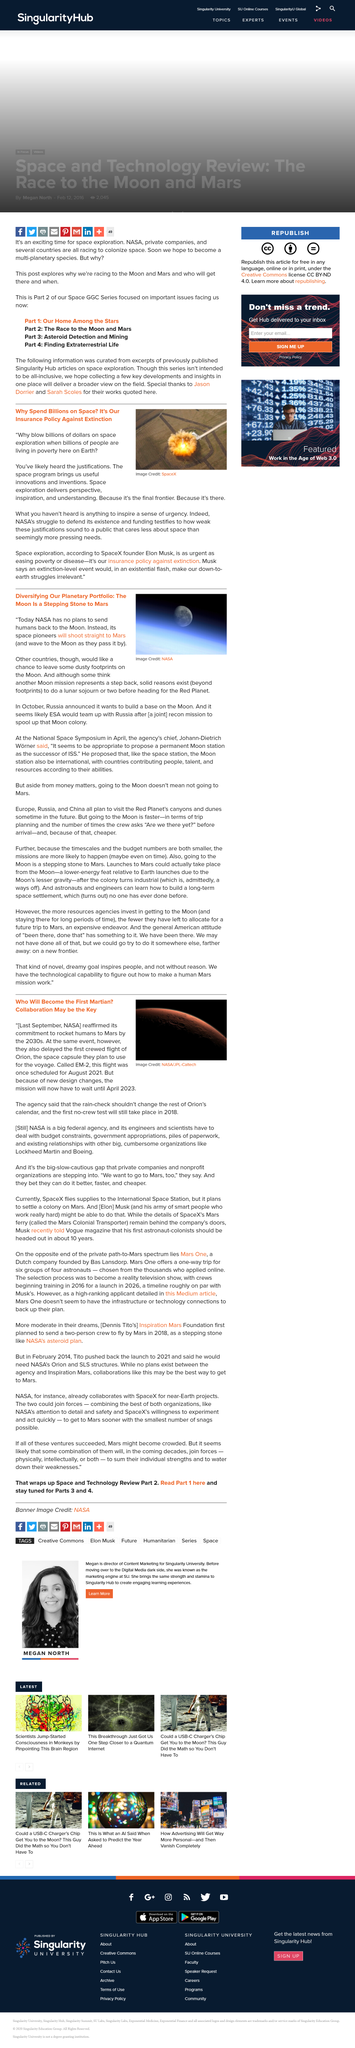Identify some key points in this picture. NASA has reiterated its intention to send humans to Mars in the 2030s. Declarative: Space pioneers will travel directly to Mars without hesitation. Nasa's struggle to fund and legitimize its existence is due to the fact that its justification for space exploration does not meet the demands and needs of the public, who see it as an unnecessary and wasteful endeavor, especially when compared to addressing more pressing issues such as poverty. The European Space Agency (ESA) will team up with Russia in the future. Space programs are frequently justified in terms of their potential to provide understanding, perspective, and inspiration, as well as to bring about useful innovations and inventions, as stated in the article. 